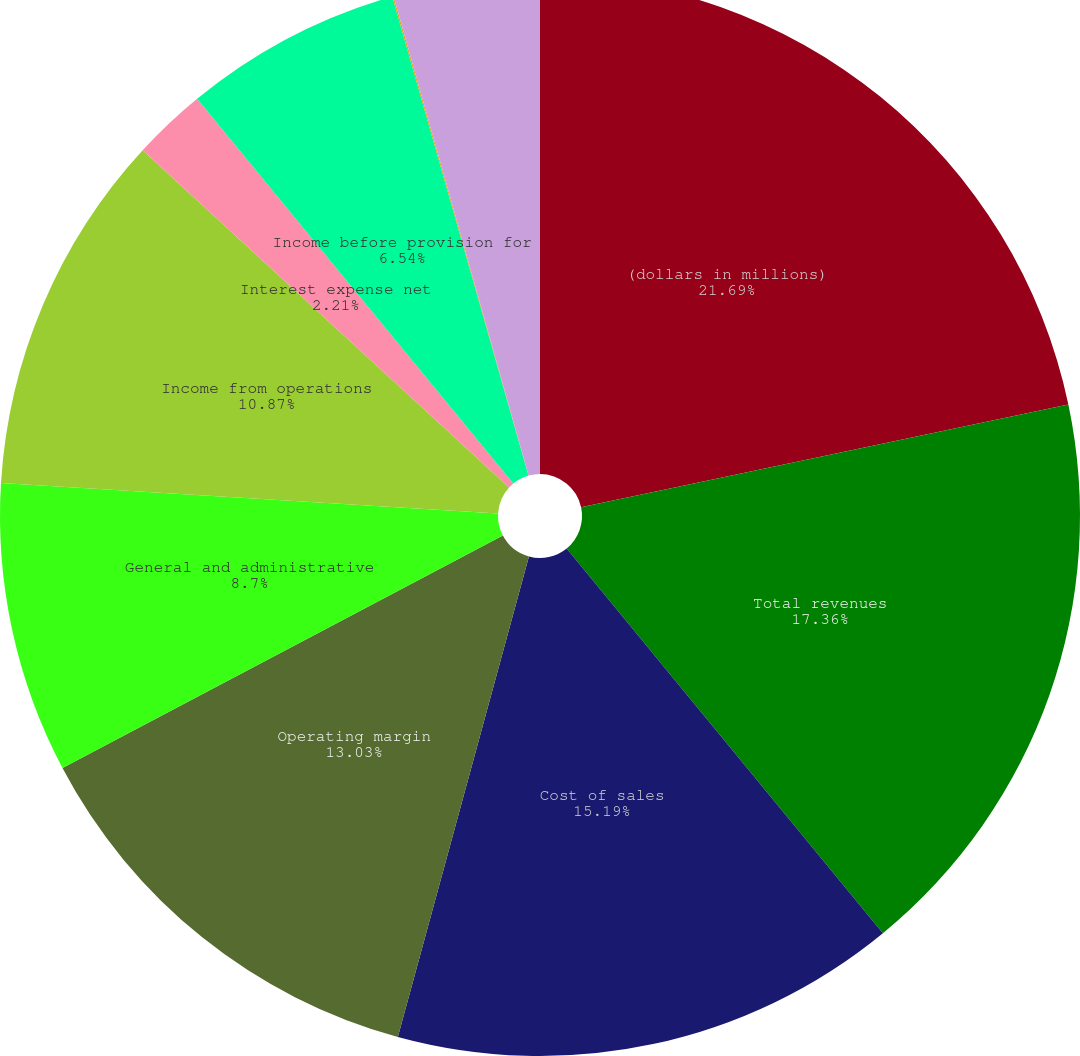Convert chart. <chart><loc_0><loc_0><loc_500><loc_500><pie_chart><fcel>(dollars in millions)<fcel>Total revenues<fcel>Cost of sales<fcel>Operating margin<fcel>General and administrative<fcel>Income from operations<fcel>Interest expense net<fcel>Income before provision for<fcel>Provision for income taxes<fcel>Net income<nl><fcel>21.69%<fcel>17.36%<fcel>15.19%<fcel>13.03%<fcel>8.7%<fcel>10.87%<fcel>2.21%<fcel>6.54%<fcel>0.04%<fcel>4.37%<nl></chart> 